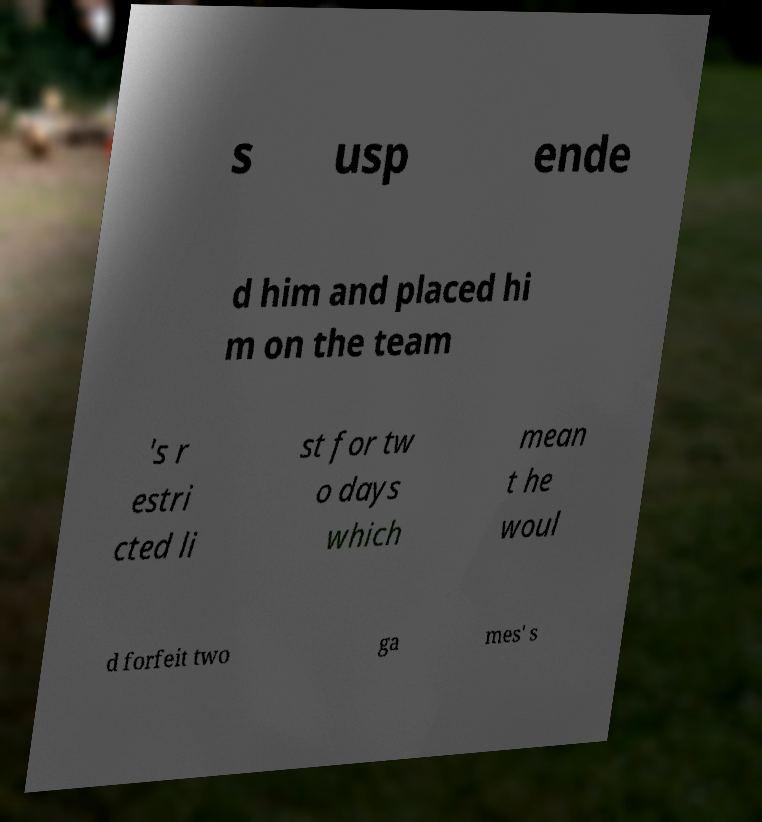Could you assist in decoding the text presented in this image and type it out clearly? s usp ende d him and placed hi m on the team 's r estri cted li st for tw o days which mean t he woul d forfeit two ga mes' s 